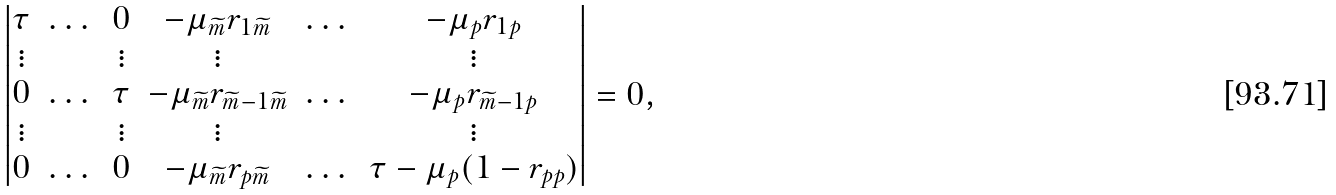<formula> <loc_0><loc_0><loc_500><loc_500>\begin{vmatrix} \tau & \dots & 0 & - \mu _ { \widetilde { m } } r _ { 1 \widetilde { m } } & \dots & - \mu _ { p } r _ { 1 p } \\ \vdots & & \vdots & \vdots & & \vdots \\ 0 & \dots & \tau & - \mu _ { \widetilde { m } } r _ { \widetilde { m } - 1 \widetilde { m } } & \dots & - \mu _ { p } r _ { \widetilde { m } - 1 p } \\ \vdots & & \vdots & \vdots & & \vdots \\ 0 & \dots & 0 & - \mu _ { \widetilde { m } } r _ { p \widetilde { m } } & \dots & \tau - \mu _ { p } ( 1 - r _ { p p } ) \end{vmatrix} = 0 ,</formula> 